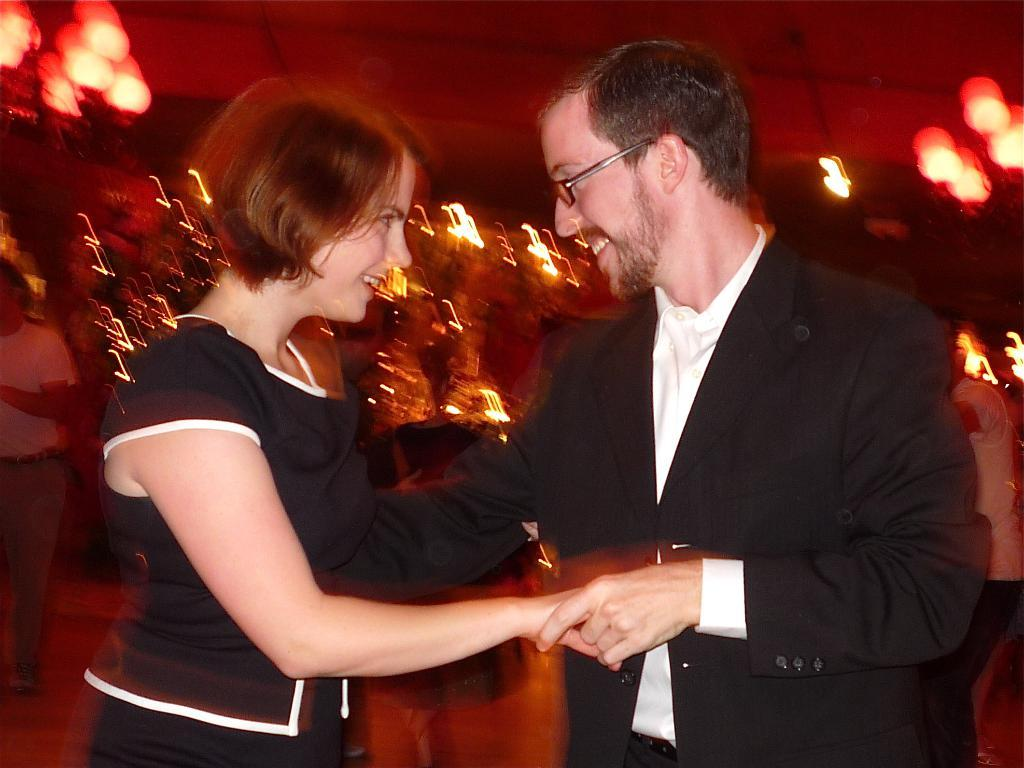Who are the people in the image? There is a man and a woman in the image. What are the man and woman doing in the image? The man and woman are dancing. Can you describe the background of the image? The background of the image is blurred. What type of approval does the judge give in the image? There is no judge present in the image, and therefore no approval can be given. 